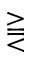Convert formula to latex. <formula><loc_0><loc_0><loc_500><loc_500>\gtreqqless</formula> 